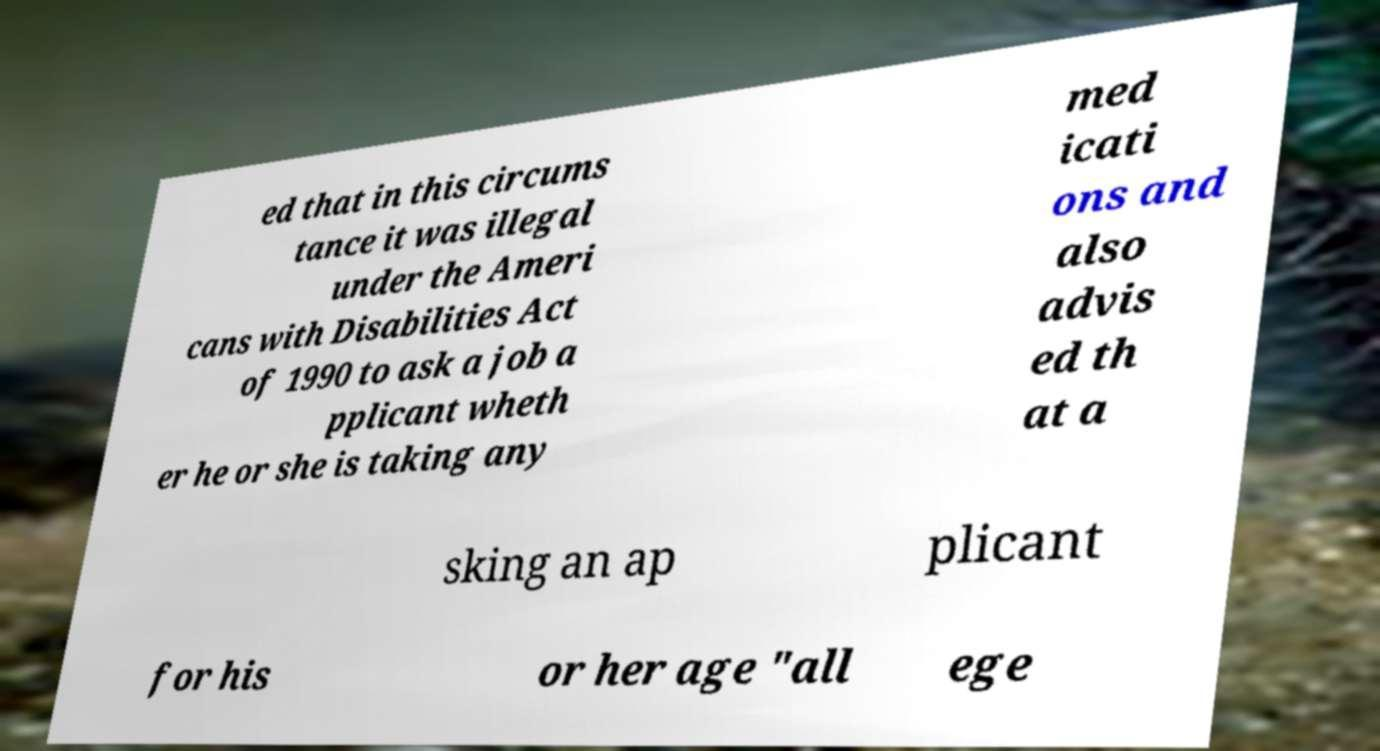For documentation purposes, I need the text within this image transcribed. Could you provide that? ed that in this circums tance it was illegal under the Ameri cans with Disabilities Act of 1990 to ask a job a pplicant wheth er he or she is taking any med icati ons and also advis ed th at a sking an ap plicant for his or her age "all ege 